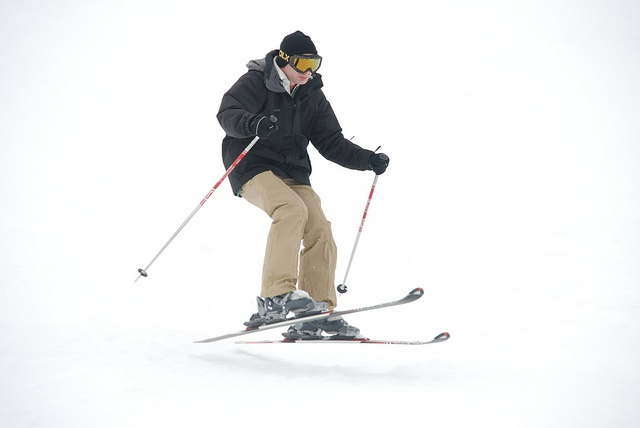Describe the objects in this image and their specific colors. I can see people in white, black, tan, and gray tones and skis in white, lightgray, darkgray, gray, and pink tones in this image. 